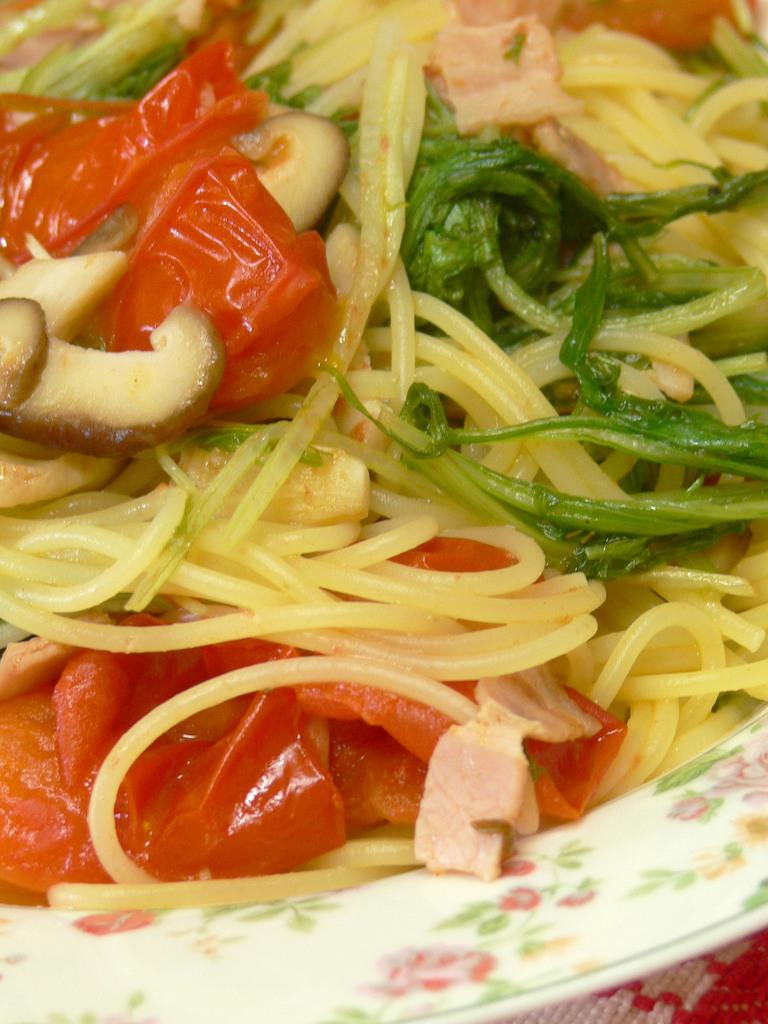What type of food item can be seen in the image? There is a food item in a bowl or a plate in the image. Can you describe the food item in more detail? Unfortunately, the specific type of food item cannot be determined from the given facts. Is the food item accompanied by any utensils or condiments? The provided facts do not mention any utensils or condiments. What type of jelly can be seen in the cemetery in the image? There is no jelly or cemetery present in the image. The image only contains a food item in a bowl or a plate. 